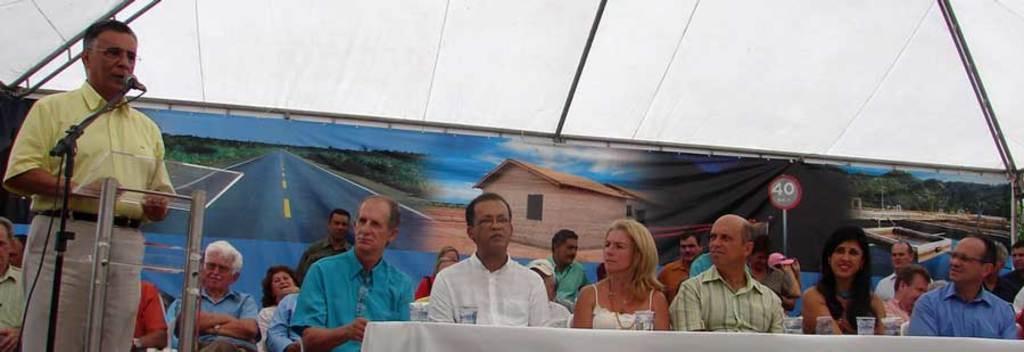In one or two sentences, can you explain what this image depicts? Here we can see some persons are sitting on the chairs. This is table. On the table there is a cloth, and glasses. Here we can see a man talking on the mike and he has spectacles. This is podium. In the background there is a banner and this is roof. On the banner we can see house, pole, board, road, trees, and sky. 